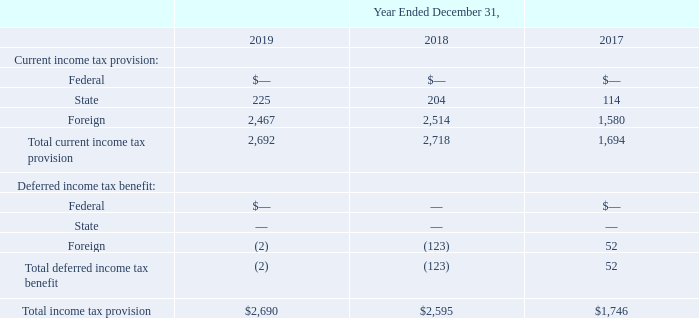The components of the provision for income taxes attributable to continuing operations are as follows (in thousands):
On a consolidated basis, the Company has incurred operating losses and has recorded a full valuation allowance against its US, UK, New Zealand, Hong Kong, and Brazil deferred tax assets for all periods to date and, accordingly, has not recorded a provision (benefit) for income taxes for any of the periods presented other than a provision (benefit) for certain foreign and state income taxes. Certain foreign subsidiaries and branches of the Company provide intercompany services and are compensated on a cost-plus basis, and therefore, have incurred liabilities for foreign income taxes in their respective jurisdictions.
Why has the company incurred liabilities for foreign income taxes? Certain foreign subsidiaries and branches of the company provide intercompany services and are compensated on a cost-plus basis. What is the provision for State income tax in 2018?
Answer scale should be: thousand. 204. What is the provision for Foreign income tax in 2019?
Answer scale should be: thousand. 2,467. What percentage of total current income tax provision consist of State income tax provisions in 2019?
Answer scale should be: percent. (225/2,692)
Answer: 8.36. What is the percentage change in state income tax provision between 2017 and 2018?
Answer scale should be: percent. (204-114)/114
Answer: 78.95. What is the change in foreign income tax provision between 2018 and 2019?
Answer scale should be: thousand. (2,467-2,514)
Answer: -47. 